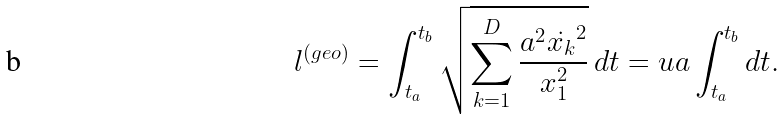<formula> <loc_0><loc_0><loc_500><loc_500>l ^ { ( g e o ) } = \int _ { t _ { a } } ^ { t _ { b } } \sqrt { \sum _ { k = 1 } ^ { D } \frac { a ^ { 2 } \dot { x _ { k } } ^ { 2 } } { x _ { 1 } ^ { 2 } } } \, d t = u a \int _ { t _ { a } } ^ { t _ { b } } d t .</formula> 